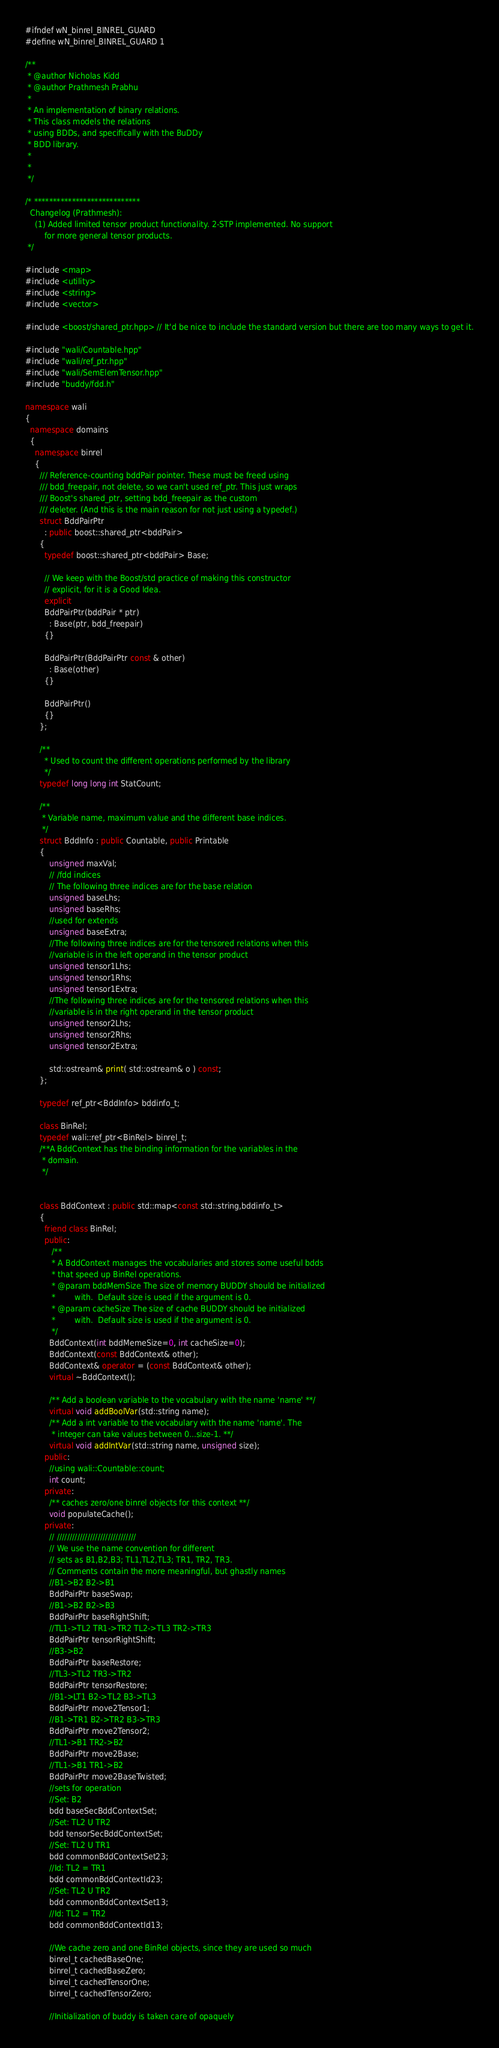<code> <loc_0><loc_0><loc_500><loc_500><_C++_>#ifndef wN_binrel_BINREL_GUARD
#define wN_binrel_BINREL_GUARD 1

/**
 * @author Nicholas Kidd
 * @author Prathmesh Prabhu
 *
 * An implementation of binary relations. 
 * This class models the relations
 * using BDDs, and specifically with the BuDDy
 * BDD library. 
 *
 *
 */

/* ****************************
  Changelog (Prathmesh):
    (1) Added limited tensor product functionality. 2-STP implemented. No support
        for more general tensor products.
 */

#include <map>
#include <utility>
#include <string>
#include <vector>

#include <boost/shared_ptr.hpp> // It'd be nice to include the standard version but there are too many ways to get it.

#include "wali/Countable.hpp"
#include "wali/ref_ptr.hpp"
#include "wali/SemElemTensor.hpp"
#include "buddy/fdd.h"

namespace wali 
{
  namespace domains 
  {
    namespace binrel 
    {
      /// Reference-counting bddPair pointer. These must be freed using
      /// bdd_freepair, not delete, so we can't used ref_ptr. This just wraps
      /// Boost's shared_ptr, setting bdd_freepair as the custom
      /// deleter. (And this is the main reason for not just using a typedef.)
      struct BddPairPtr
        : public boost::shared_ptr<bddPair>
      {
        typedef boost::shared_ptr<bddPair> Base;
        
        // We keep with the Boost/std practice of making this constructor
        // explicit, for it is a Good Idea.
        explicit
        BddPairPtr(bddPair * ptr)
          : Base(ptr, bdd_freepair)
        {}

        BddPairPtr(BddPairPtr const & other)
          : Base(other)
        {}

        BddPairPtr()
        {}
      };

      /**
        * Used to count the different operations performed by the library
        */
      typedef long long int StatCount;

      /**
       * Variable name, maximum value and the different base indices.
       */
      struct BddInfo : public Countable, public Printable
      {
          unsigned maxVal;
          // /fdd indices
          // The following three indices are for the base relation
          unsigned baseLhs;
          unsigned baseRhs;
          //used for extends
          unsigned baseExtra;
          //The following three indices are for the tensored relations when this
          //variable is in the left operand in the tensor product
          unsigned tensor1Lhs;
          unsigned tensor1Rhs;
          unsigned tensor1Extra;
          //The following three indices are for the tensored relations when this
          //variable is in the right operand in the tensor product
          unsigned tensor2Lhs;
          unsigned tensor2Rhs;
          unsigned tensor2Extra;

          std::ostream& print( std::ostream& o ) const;
      };
        
      typedef ref_ptr<BddInfo> bddinfo_t;

      class BinRel;
      typedef wali::ref_ptr<BinRel> binrel_t;
      /**A BddContext has the binding information for the variables in the
       * domain.
       */


      class BddContext : public std::map<const std::string,bddinfo_t>
      {
        friend class BinRel;
        public:
           /** 
           * A BddContext manages the vocabularies and stores some useful bdds
           * that speed up BinRel operations.
           * @param bddMemSize The size of memory BUDDY should be initialized
           *        with.  Default size is used if the argument is 0.  
           * @param cacheSize The size of cache BUDDY should be initialized
           *        with.  Default size is used if the argument is 0.
           */
          BddContext(int bddMemeSize=0, int cacheSize=0);
          BddContext(const BddContext& other);
          BddContext& operator = (const BddContext& other);
          virtual ~BddContext();

          /** Add a boolean variable to the vocabulary with the name 'name' **/
          virtual void addBoolVar(std::string name);
          /** Add a int variable to the vocabulary with the name 'name'. The
           * integer can take values between 0...size-1. **/
          virtual void addIntVar(std::string name, unsigned size);
        public:
          //using wali::Countable::count;
          int count;
        private:
          /** caches zero/one binrel objects for this context **/
          void populateCache();
        private:
          // ///////////////////////////////
          // We use the name convention for different 
          // sets as B1,B2,B3; TL1,TL2,TL3; TR1, TR2, TR3.
          // Comments contain the more meaningful, but ghastly names
          //B1->B2 B2->B1
          BddPairPtr baseSwap;
          //B1->B2 B2->B3
          BddPairPtr baseRightShift;
          //TL1->TL2 TR1->TR2 TL2->TL3 TR2->TR3 
          BddPairPtr tensorRightShift; 
          //B3->B2
          BddPairPtr baseRestore;
          //TL3->TL2 TR3->TR2
          BddPairPtr tensorRestore;
          //B1->LT1 B2->TL2 B3->TL3
          BddPairPtr move2Tensor1;
          //B1->TR1 B2->TR2 B3->TR3
          BddPairPtr move2Tensor2;
          //TL1->B1 TR2->B2
          BddPairPtr move2Base;
          //TL1->B1 TR1->B2
          BddPairPtr move2BaseTwisted;
          //sets for operation
          //Set: B2
          bdd baseSecBddContextSet;
          //Set: TL2 U TR2
          bdd tensorSecBddContextSet;
          //Set: TL2 U TR1
          bdd commonBddContextSet23;
          //Id: TL2 = TR1
          bdd commonBddContextId23;
          //Set: TL2 U TR2
          bdd commonBddContextSet13;
          //Id: TL2 = TR2
          bdd commonBddContextId13;

          //We cache zero and one BinRel objects, since they are used so much
          binrel_t cachedBaseOne;
          binrel_t cachedBaseZero;
          binrel_t cachedTensorOne;
          binrel_t cachedTensorZero;

          //Initialization of buddy is taken care of opaquely </code> 